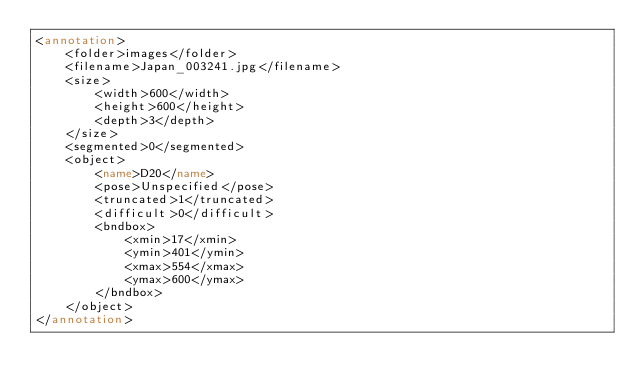Convert code to text. <code><loc_0><loc_0><loc_500><loc_500><_XML_><annotation>
	<folder>images</folder>
	<filename>Japan_003241.jpg</filename>
	<size>
		<width>600</width>
		<height>600</height>
		<depth>3</depth>
	</size>
	<segmented>0</segmented>
	<object>
		<name>D20</name>
		<pose>Unspecified</pose>
		<truncated>1</truncated>
		<difficult>0</difficult>
		<bndbox>
			<xmin>17</xmin>
			<ymin>401</ymin>
			<xmax>554</xmax>
			<ymax>600</ymax>
		</bndbox>
	</object>
</annotation></code> 